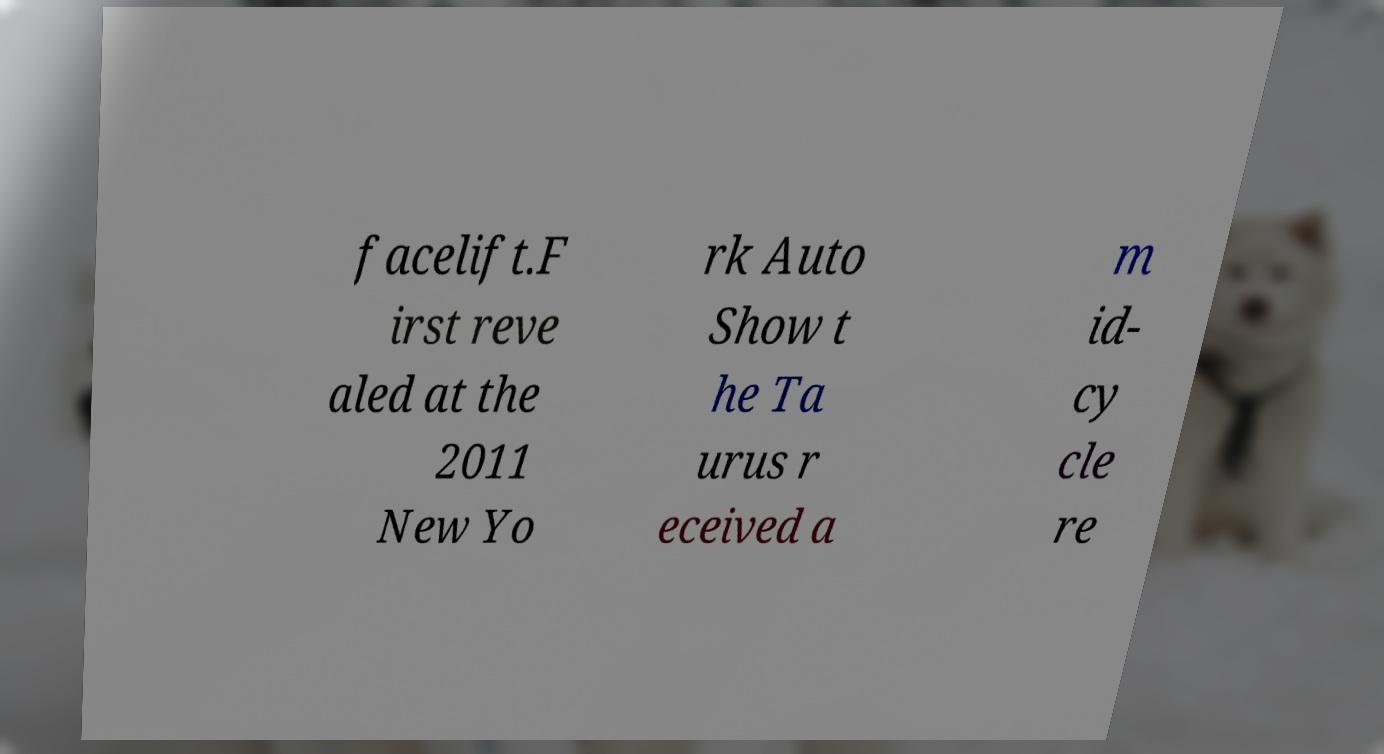Can you accurately transcribe the text from the provided image for me? facelift.F irst reve aled at the 2011 New Yo rk Auto Show t he Ta urus r eceived a m id- cy cle re 